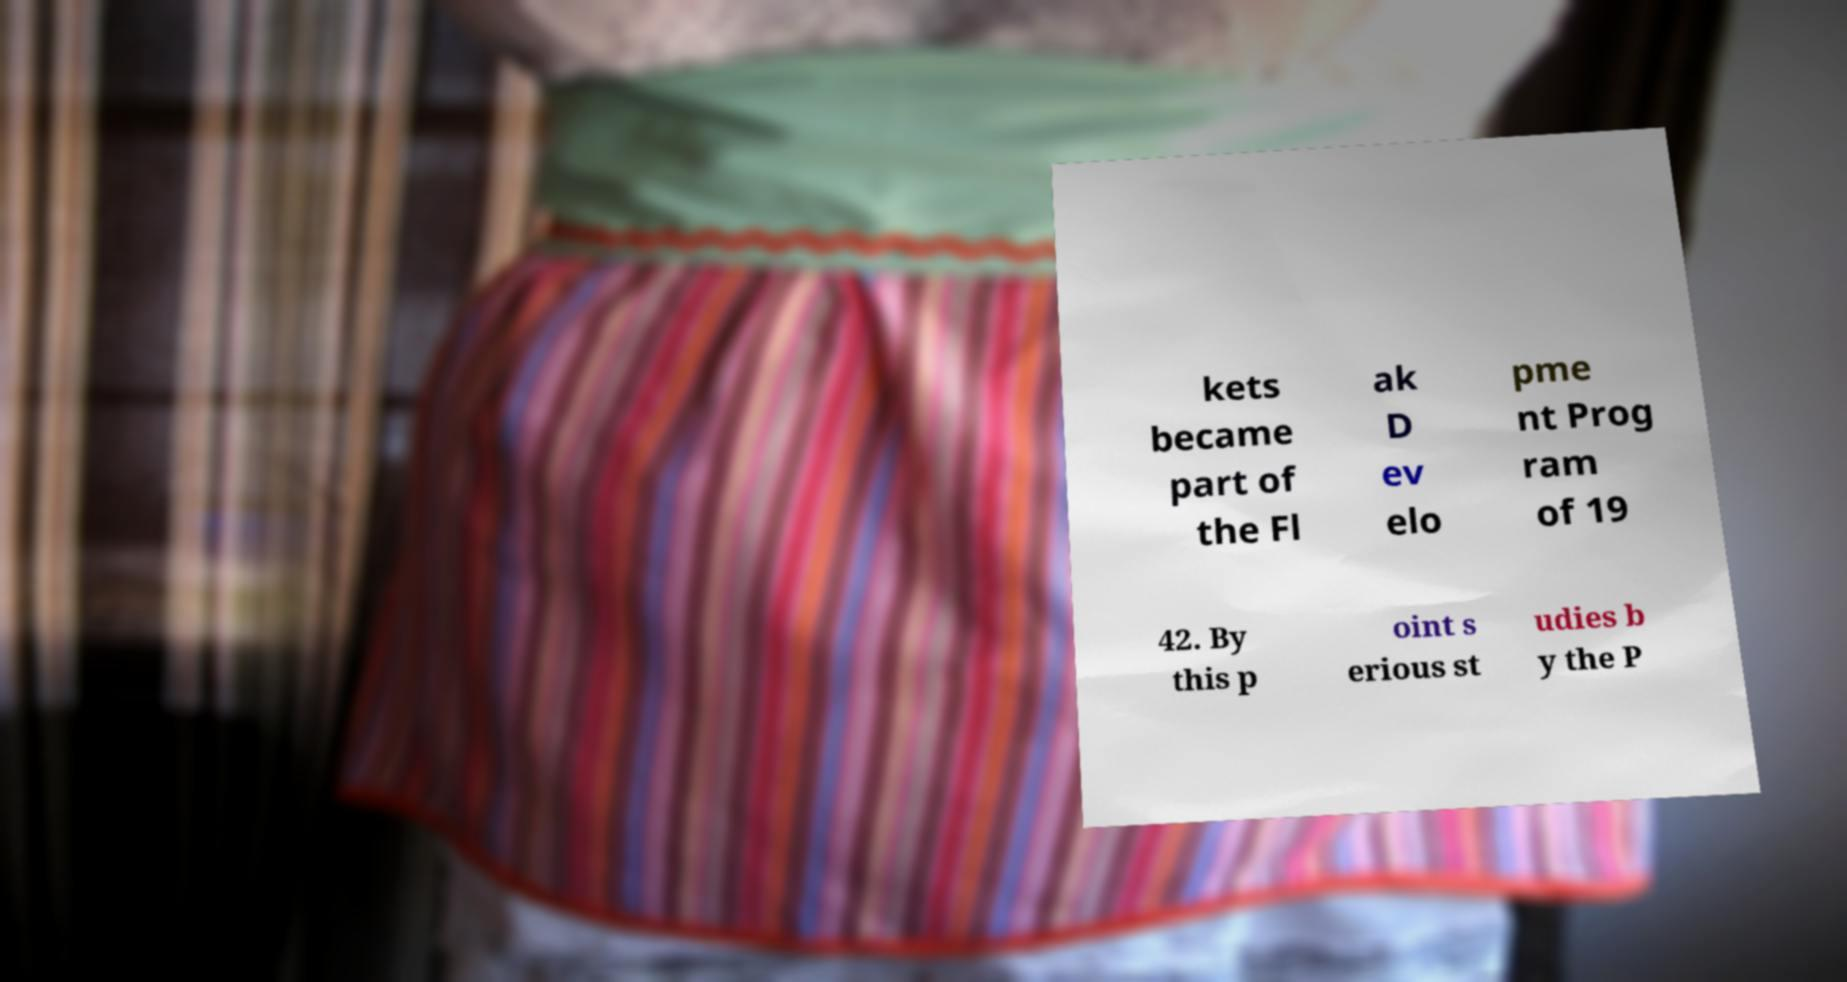Can you read and provide the text displayed in the image?This photo seems to have some interesting text. Can you extract and type it out for me? kets became part of the Fl ak D ev elo pme nt Prog ram of 19 42. By this p oint s erious st udies b y the P 